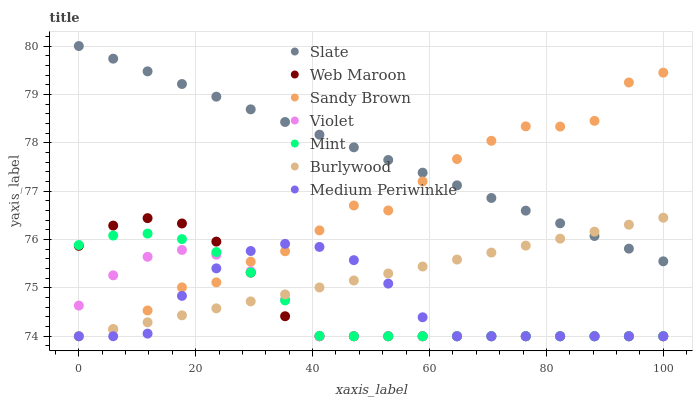Does Violet have the minimum area under the curve?
Answer yes or no. Yes. Does Slate have the maximum area under the curve?
Answer yes or no. Yes. Does Burlywood have the minimum area under the curve?
Answer yes or no. No. Does Burlywood have the maximum area under the curve?
Answer yes or no. No. Is Slate the smoothest?
Answer yes or no. Yes. Is Sandy Brown the roughest?
Answer yes or no. Yes. Is Burlywood the smoothest?
Answer yes or no. No. Is Burlywood the roughest?
Answer yes or no. No. Does Medium Periwinkle have the lowest value?
Answer yes or no. Yes. Does Slate have the lowest value?
Answer yes or no. No. Does Slate have the highest value?
Answer yes or no. Yes. Does Burlywood have the highest value?
Answer yes or no. No. Is Mint less than Slate?
Answer yes or no. Yes. Is Slate greater than Web Maroon?
Answer yes or no. Yes. Does Burlywood intersect Violet?
Answer yes or no. Yes. Is Burlywood less than Violet?
Answer yes or no. No. Is Burlywood greater than Violet?
Answer yes or no. No. Does Mint intersect Slate?
Answer yes or no. No. 